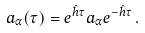Convert formula to latex. <formula><loc_0><loc_0><loc_500><loc_500>a _ { \alpha } ( \tau ) = e ^ { \hat { h } \tau } a _ { \alpha } e ^ { - \hat { h } \tau } \, .</formula> 